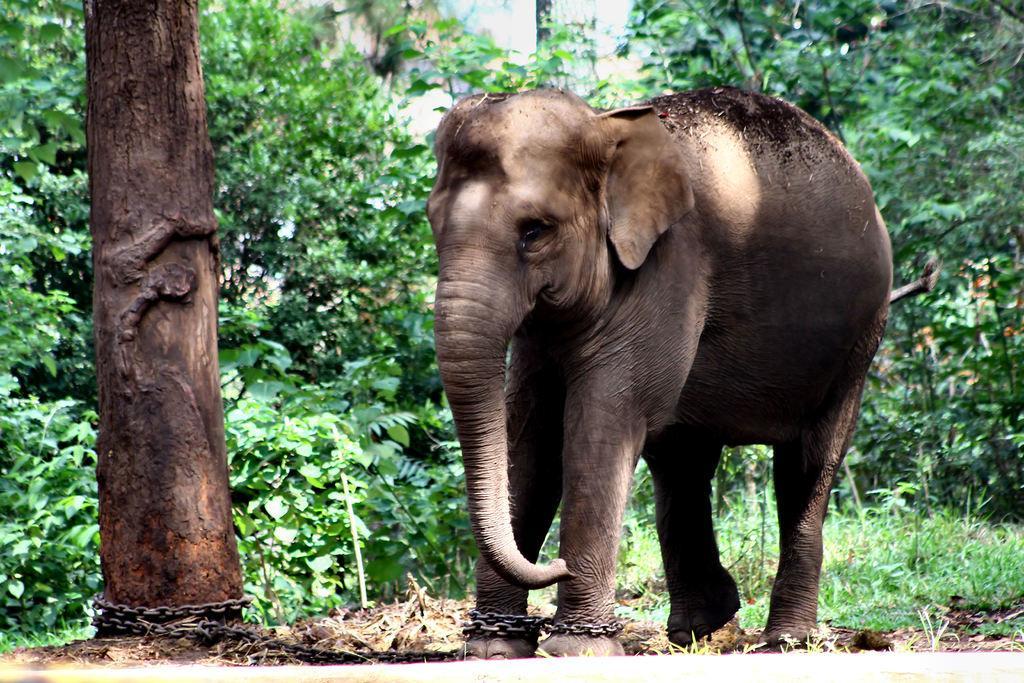Can you describe this image briefly? This is an elephant standing, which is tied with an iron chain. Here is the tree trunk. In the background, I can see the trees and plants. This looks like the grass. 